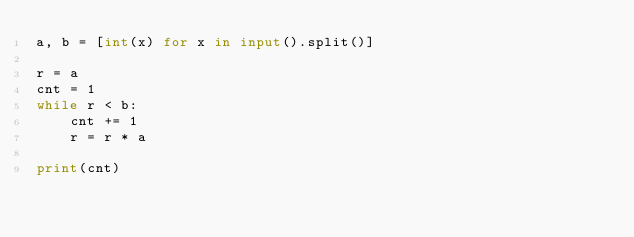<code> <loc_0><loc_0><loc_500><loc_500><_Python_>a, b = [int(x) for x in input().split()]

r = a
cnt = 1
while r < b:
	cnt += 1
	r = r * a

print(cnt)</code> 